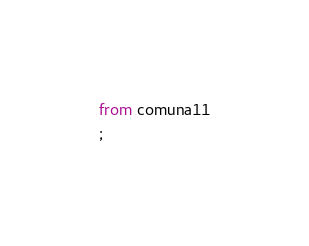<code> <loc_0><loc_0><loc_500><loc_500><_SQL_>from comuna11
;
</code> 